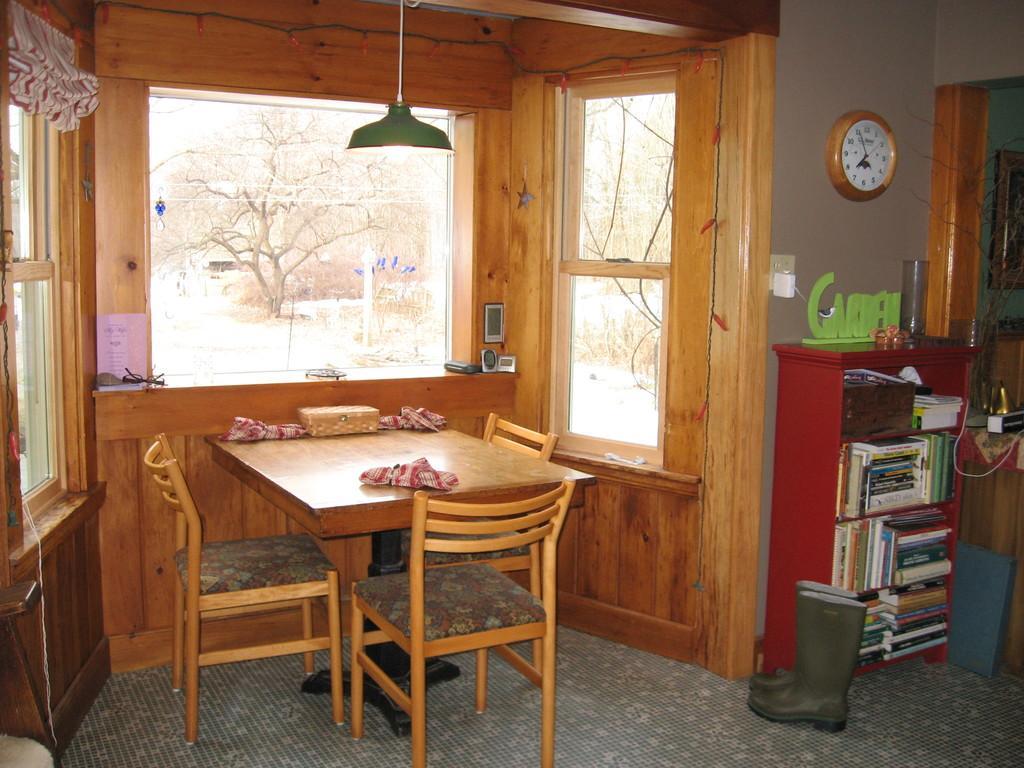Could you give a brief overview of what you see in this image? This image is taken inside the room, where we can see there is a dining table in the middle. Around the table there are chairs. On the right side there is a cupboard in which there are books. At the bottom there are boots on the floor. On the right side there is wall clock attached to the wall. In the middle there is a light which is hanging. On the left side there is a window. At the top of the window there is a curtain. 